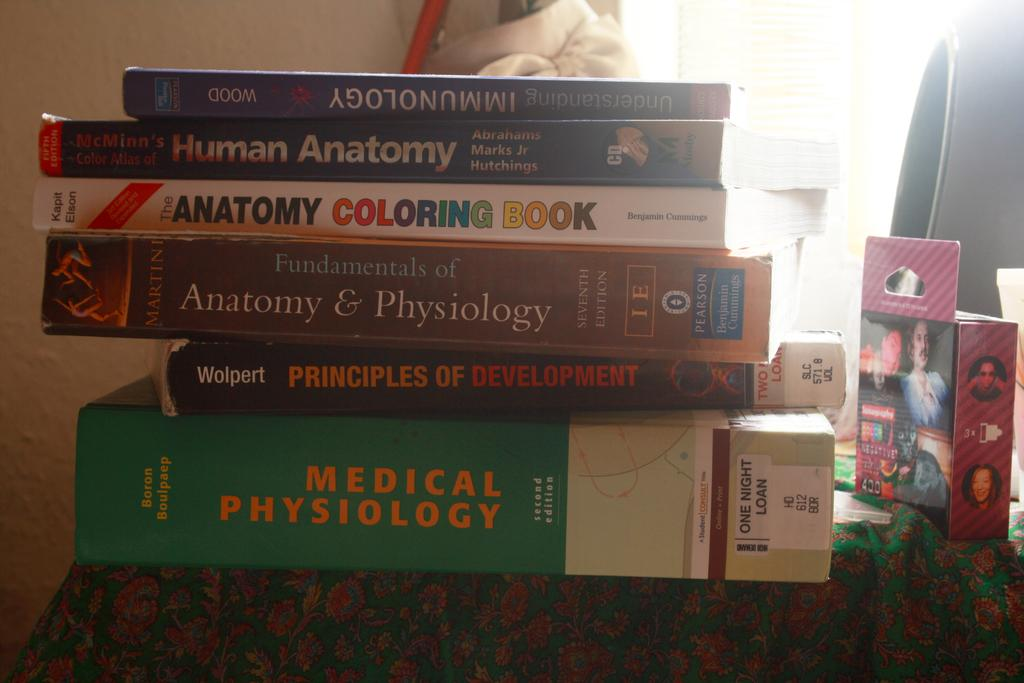<image>
Relay a brief, clear account of the picture shown. Medical Phsyiology book on bottom and Immunology book in blue on top. 